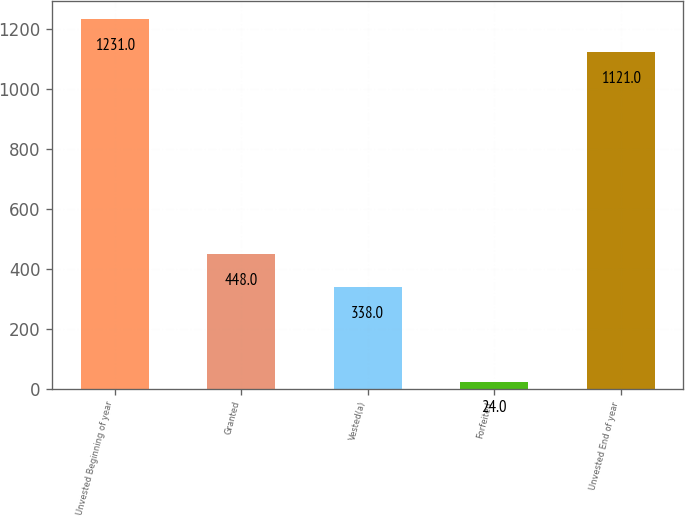<chart> <loc_0><loc_0><loc_500><loc_500><bar_chart><fcel>Unvested Beginning of year<fcel>Granted<fcel>Vested(a)<fcel>Forfeited<fcel>Unvested End of year<nl><fcel>1231<fcel>448<fcel>338<fcel>24<fcel>1121<nl></chart> 